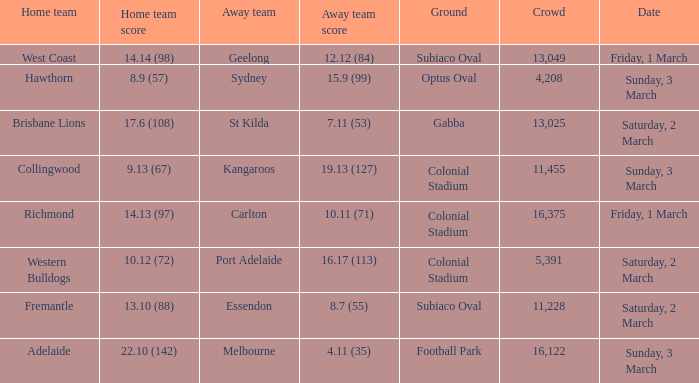What was the ground for away team sydney? Optus Oval. 